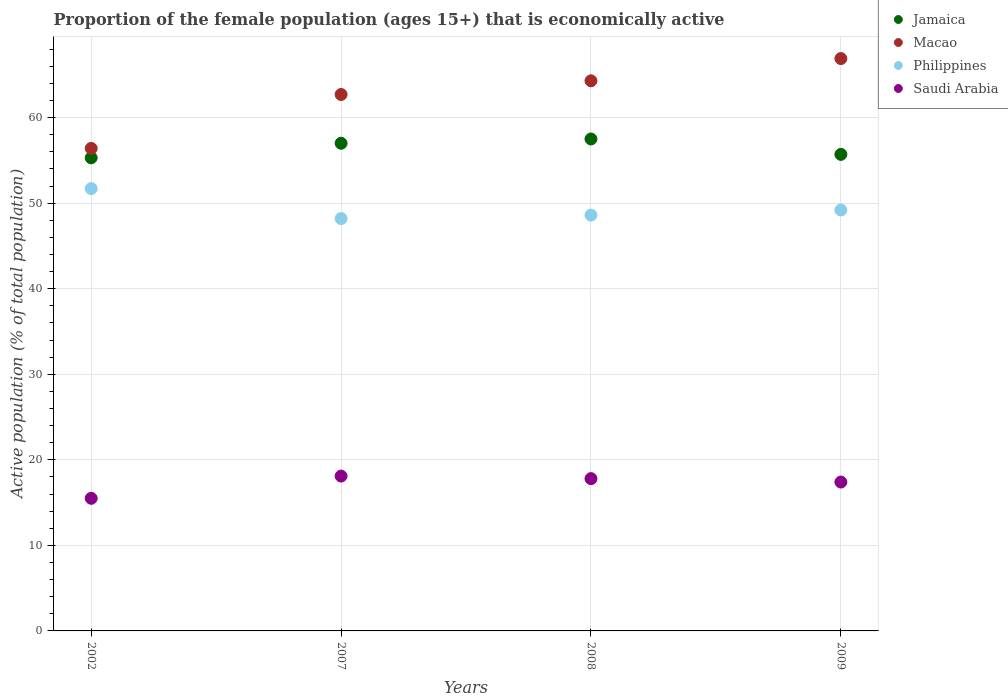Is the number of dotlines equal to the number of legend labels?
Your response must be concise. Yes. What is the proportion of the female population that is economically active in Saudi Arabia in 2008?
Keep it short and to the point. 17.8. Across all years, what is the maximum proportion of the female population that is economically active in Saudi Arabia?
Your response must be concise. 18.1. Across all years, what is the minimum proportion of the female population that is economically active in Saudi Arabia?
Offer a very short reply. 15.5. In which year was the proportion of the female population that is economically active in Philippines maximum?
Provide a short and direct response. 2002. What is the total proportion of the female population that is economically active in Philippines in the graph?
Provide a short and direct response. 197.7. What is the difference between the proportion of the female population that is economically active in Jamaica in 2007 and that in 2009?
Keep it short and to the point. 1.3. What is the difference between the proportion of the female population that is economically active in Jamaica in 2008 and the proportion of the female population that is economically active in Saudi Arabia in 2007?
Your answer should be compact. 39.4. What is the average proportion of the female population that is economically active in Philippines per year?
Your answer should be very brief. 49.43. In the year 2002, what is the difference between the proportion of the female population that is economically active in Philippines and proportion of the female population that is economically active in Saudi Arabia?
Provide a succinct answer. 36.2. What is the ratio of the proportion of the female population that is economically active in Saudi Arabia in 2007 to that in 2009?
Your response must be concise. 1.04. Is the difference between the proportion of the female population that is economically active in Philippines in 2002 and 2007 greater than the difference between the proportion of the female population that is economically active in Saudi Arabia in 2002 and 2007?
Your answer should be compact. Yes. What is the difference between the highest and the lowest proportion of the female population that is economically active in Macao?
Give a very brief answer. 10.5. Is the sum of the proportion of the female population that is economically active in Macao in 2002 and 2009 greater than the maximum proportion of the female population that is economically active in Saudi Arabia across all years?
Offer a terse response. Yes. Is it the case that in every year, the sum of the proportion of the female population that is economically active in Saudi Arabia and proportion of the female population that is economically active in Philippines  is greater than the sum of proportion of the female population that is economically active in Jamaica and proportion of the female population that is economically active in Macao?
Make the answer very short. Yes. Is it the case that in every year, the sum of the proportion of the female population that is economically active in Philippines and proportion of the female population that is economically active in Macao  is greater than the proportion of the female population that is economically active in Jamaica?
Ensure brevity in your answer.  Yes. Is the proportion of the female population that is economically active in Philippines strictly greater than the proportion of the female population that is economically active in Jamaica over the years?
Your answer should be very brief. No. Is the proportion of the female population that is economically active in Jamaica strictly less than the proportion of the female population that is economically active in Saudi Arabia over the years?
Provide a short and direct response. No. How many dotlines are there?
Your answer should be compact. 4. What is the difference between two consecutive major ticks on the Y-axis?
Your response must be concise. 10. Are the values on the major ticks of Y-axis written in scientific E-notation?
Your answer should be very brief. No. Does the graph contain any zero values?
Give a very brief answer. No. Where does the legend appear in the graph?
Provide a short and direct response. Top right. How many legend labels are there?
Ensure brevity in your answer.  4. What is the title of the graph?
Provide a short and direct response. Proportion of the female population (ages 15+) that is economically active. Does "Upper middle income" appear as one of the legend labels in the graph?
Your answer should be very brief. No. What is the label or title of the X-axis?
Make the answer very short. Years. What is the label or title of the Y-axis?
Offer a very short reply. Active population (% of total population). What is the Active population (% of total population) in Jamaica in 2002?
Give a very brief answer. 55.3. What is the Active population (% of total population) in Macao in 2002?
Provide a succinct answer. 56.4. What is the Active population (% of total population) of Philippines in 2002?
Offer a very short reply. 51.7. What is the Active population (% of total population) of Macao in 2007?
Your answer should be compact. 62.7. What is the Active population (% of total population) in Philippines in 2007?
Give a very brief answer. 48.2. What is the Active population (% of total population) of Saudi Arabia in 2007?
Offer a very short reply. 18.1. What is the Active population (% of total population) of Jamaica in 2008?
Provide a succinct answer. 57.5. What is the Active population (% of total population) in Macao in 2008?
Ensure brevity in your answer.  64.3. What is the Active population (% of total population) in Philippines in 2008?
Offer a terse response. 48.6. What is the Active population (% of total population) in Saudi Arabia in 2008?
Make the answer very short. 17.8. What is the Active population (% of total population) in Jamaica in 2009?
Give a very brief answer. 55.7. What is the Active population (% of total population) in Macao in 2009?
Your response must be concise. 66.9. What is the Active population (% of total population) in Philippines in 2009?
Provide a succinct answer. 49.2. What is the Active population (% of total population) of Saudi Arabia in 2009?
Offer a very short reply. 17.4. Across all years, what is the maximum Active population (% of total population) in Jamaica?
Your answer should be very brief. 57.5. Across all years, what is the maximum Active population (% of total population) of Macao?
Ensure brevity in your answer.  66.9. Across all years, what is the maximum Active population (% of total population) of Philippines?
Your answer should be compact. 51.7. Across all years, what is the maximum Active population (% of total population) of Saudi Arabia?
Your response must be concise. 18.1. Across all years, what is the minimum Active population (% of total population) in Jamaica?
Give a very brief answer. 55.3. Across all years, what is the minimum Active population (% of total population) of Macao?
Make the answer very short. 56.4. Across all years, what is the minimum Active population (% of total population) of Philippines?
Your answer should be compact. 48.2. What is the total Active population (% of total population) in Jamaica in the graph?
Offer a terse response. 225.5. What is the total Active population (% of total population) in Macao in the graph?
Offer a very short reply. 250.3. What is the total Active population (% of total population) in Philippines in the graph?
Your answer should be very brief. 197.7. What is the total Active population (% of total population) in Saudi Arabia in the graph?
Provide a succinct answer. 68.8. What is the difference between the Active population (% of total population) of Jamaica in 2002 and that in 2007?
Give a very brief answer. -1.7. What is the difference between the Active population (% of total population) in Macao in 2002 and that in 2007?
Provide a short and direct response. -6.3. What is the difference between the Active population (% of total population) of Macao in 2002 and that in 2008?
Provide a short and direct response. -7.9. What is the difference between the Active population (% of total population) in Philippines in 2002 and that in 2008?
Your answer should be compact. 3.1. What is the difference between the Active population (% of total population) of Saudi Arabia in 2002 and that in 2008?
Provide a short and direct response. -2.3. What is the difference between the Active population (% of total population) of Macao in 2002 and that in 2009?
Provide a short and direct response. -10.5. What is the difference between the Active population (% of total population) in Saudi Arabia in 2002 and that in 2009?
Your answer should be compact. -1.9. What is the difference between the Active population (% of total population) of Macao in 2007 and that in 2008?
Your answer should be compact. -1.6. What is the difference between the Active population (% of total population) in Jamaica in 2007 and that in 2009?
Your answer should be very brief. 1.3. What is the difference between the Active population (% of total population) of Jamaica in 2008 and that in 2009?
Ensure brevity in your answer.  1.8. What is the difference between the Active population (% of total population) of Macao in 2008 and that in 2009?
Your response must be concise. -2.6. What is the difference between the Active population (% of total population) of Jamaica in 2002 and the Active population (% of total population) of Macao in 2007?
Provide a short and direct response. -7.4. What is the difference between the Active population (% of total population) of Jamaica in 2002 and the Active population (% of total population) of Saudi Arabia in 2007?
Provide a succinct answer. 37.2. What is the difference between the Active population (% of total population) in Macao in 2002 and the Active population (% of total population) in Philippines in 2007?
Provide a short and direct response. 8.2. What is the difference between the Active population (% of total population) in Macao in 2002 and the Active population (% of total population) in Saudi Arabia in 2007?
Provide a succinct answer. 38.3. What is the difference between the Active population (% of total population) in Philippines in 2002 and the Active population (% of total population) in Saudi Arabia in 2007?
Offer a very short reply. 33.6. What is the difference between the Active population (% of total population) of Jamaica in 2002 and the Active population (% of total population) of Saudi Arabia in 2008?
Provide a succinct answer. 37.5. What is the difference between the Active population (% of total population) in Macao in 2002 and the Active population (% of total population) in Saudi Arabia in 2008?
Offer a terse response. 38.6. What is the difference between the Active population (% of total population) of Philippines in 2002 and the Active population (% of total population) of Saudi Arabia in 2008?
Provide a succinct answer. 33.9. What is the difference between the Active population (% of total population) of Jamaica in 2002 and the Active population (% of total population) of Macao in 2009?
Provide a short and direct response. -11.6. What is the difference between the Active population (% of total population) of Jamaica in 2002 and the Active population (% of total population) of Philippines in 2009?
Keep it short and to the point. 6.1. What is the difference between the Active population (% of total population) of Jamaica in 2002 and the Active population (% of total population) of Saudi Arabia in 2009?
Give a very brief answer. 37.9. What is the difference between the Active population (% of total population) of Macao in 2002 and the Active population (% of total population) of Saudi Arabia in 2009?
Offer a very short reply. 39. What is the difference between the Active population (% of total population) of Philippines in 2002 and the Active population (% of total population) of Saudi Arabia in 2009?
Make the answer very short. 34.3. What is the difference between the Active population (% of total population) of Jamaica in 2007 and the Active population (% of total population) of Macao in 2008?
Your answer should be very brief. -7.3. What is the difference between the Active population (% of total population) in Jamaica in 2007 and the Active population (% of total population) in Philippines in 2008?
Provide a succinct answer. 8.4. What is the difference between the Active population (% of total population) in Jamaica in 2007 and the Active population (% of total population) in Saudi Arabia in 2008?
Keep it short and to the point. 39.2. What is the difference between the Active population (% of total population) in Macao in 2007 and the Active population (% of total population) in Philippines in 2008?
Your response must be concise. 14.1. What is the difference between the Active population (% of total population) in Macao in 2007 and the Active population (% of total population) in Saudi Arabia in 2008?
Keep it short and to the point. 44.9. What is the difference between the Active population (% of total population) of Philippines in 2007 and the Active population (% of total population) of Saudi Arabia in 2008?
Keep it short and to the point. 30.4. What is the difference between the Active population (% of total population) in Jamaica in 2007 and the Active population (% of total population) in Macao in 2009?
Your answer should be very brief. -9.9. What is the difference between the Active population (% of total population) of Jamaica in 2007 and the Active population (% of total population) of Saudi Arabia in 2009?
Make the answer very short. 39.6. What is the difference between the Active population (% of total population) in Macao in 2007 and the Active population (% of total population) in Philippines in 2009?
Offer a very short reply. 13.5. What is the difference between the Active population (% of total population) in Macao in 2007 and the Active population (% of total population) in Saudi Arabia in 2009?
Your answer should be very brief. 45.3. What is the difference between the Active population (% of total population) in Philippines in 2007 and the Active population (% of total population) in Saudi Arabia in 2009?
Give a very brief answer. 30.8. What is the difference between the Active population (% of total population) in Jamaica in 2008 and the Active population (% of total population) in Saudi Arabia in 2009?
Offer a terse response. 40.1. What is the difference between the Active population (% of total population) of Macao in 2008 and the Active population (% of total population) of Saudi Arabia in 2009?
Offer a very short reply. 46.9. What is the difference between the Active population (% of total population) of Philippines in 2008 and the Active population (% of total population) of Saudi Arabia in 2009?
Keep it short and to the point. 31.2. What is the average Active population (% of total population) in Jamaica per year?
Offer a very short reply. 56.38. What is the average Active population (% of total population) in Macao per year?
Give a very brief answer. 62.58. What is the average Active population (% of total population) in Philippines per year?
Keep it short and to the point. 49.42. What is the average Active population (% of total population) in Saudi Arabia per year?
Your response must be concise. 17.2. In the year 2002, what is the difference between the Active population (% of total population) of Jamaica and Active population (% of total population) of Macao?
Your answer should be very brief. -1.1. In the year 2002, what is the difference between the Active population (% of total population) of Jamaica and Active population (% of total population) of Philippines?
Provide a succinct answer. 3.6. In the year 2002, what is the difference between the Active population (% of total population) in Jamaica and Active population (% of total population) in Saudi Arabia?
Offer a terse response. 39.8. In the year 2002, what is the difference between the Active population (% of total population) of Macao and Active population (% of total population) of Philippines?
Your response must be concise. 4.7. In the year 2002, what is the difference between the Active population (% of total population) in Macao and Active population (% of total population) in Saudi Arabia?
Your answer should be very brief. 40.9. In the year 2002, what is the difference between the Active population (% of total population) in Philippines and Active population (% of total population) in Saudi Arabia?
Your response must be concise. 36.2. In the year 2007, what is the difference between the Active population (% of total population) in Jamaica and Active population (% of total population) in Saudi Arabia?
Your answer should be very brief. 38.9. In the year 2007, what is the difference between the Active population (% of total population) of Macao and Active population (% of total population) of Philippines?
Your answer should be very brief. 14.5. In the year 2007, what is the difference between the Active population (% of total population) of Macao and Active population (% of total population) of Saudi Arabia?
Your response must be concise. 44.6. In the year 2007, what is the difference between the Active population (% of total population) in Philippines and Active population (% of total population) in Saudi Arabia?
Offer a terse response. 30.1. In the year 2008, what is the difference between the Active population (% of total population) in Jamaica and Active population (% of total population) in Macao?
Your answer should be compact. -6.8. In the year 2008, what is the difference between the Active population (% of total population) in Jamaica and Active population (% of total population) in Saudi Arabia?
Ensure brevity in your answer.  39.7. In the year 2008, what is the difference between the Active population (% of total population) in Macao and Active population (% of total population) in Philippines?
Provide a short and direct response. 15.7. In the year 2008, what is the difference between the Active population (% of total population) in Macao and Active population (% of total population) in Saudi Arabia?
Your answer should be very brief. 46.5. In the year 2008, what is the difference between the Active population (% of total population) of Philippines and Active population (% of total population) of Saudi Arabia?
Provide a short and direct response. 30.8. In the year 2009, what is the difference between the Active population (% of total population) of Jamaica and Active population (% of total population) of Saudi Arabia?
Offer a terse response. 38.3. In the year 2009, what is the difference between the Active population (% of total population) in Macao and Active population (% of total population) in Saudi Arabia?
Your answer should be very brief. 49.5. In the year 2009, what is the difference between the Active population (% of total population) of Philippines and Active population (% of total population) of Saudi Arabia?
Your answer should be very brief. 31.8. What is the ratio of the Active population (% of total population) of Jamaica in 2002 to that in 2007?
Make the answer very short. 0.97. What is the ratio of the Active population (% of total population) of Macao in 2002 to that in 2007?
Make the answer very short. 0.9. What is the ratio of the Active population (% of total population) of Philippines in 2002 to that in 2007?
Your answer should be compact. 1.07. What is the ratio of the Active population (% of total population) in Saudi Arabia in 2002 to that in 2007?
Your response must be concise. 0.86. What is the ratio of the Active population (% of total population) of Jamaica in 2002 to that in 2008?
Your response must be concise. 0.96. What is the ratio of the Active population (% of total population) of Macao in 2002 to that in 2008?
Provide a short and direct response. 0.88. What is the ratio of the Active population (% of total population) of Philippines in 2002 to that in 2008?
Keep it short and to the point. 1.06. What is the ratio of the Active population (% of total population) of Saudi Arabia in 2002 to that in 2008?
Give a very brief answer. 0.87. What is the ratio of the Active population (% of total population) in Jamaica in 2002 to that in 2009?
Your response must be concise. 0.99. What is the ratio of the Active population (% of total population) of Macao in 2002 to that in 2009?
Keep it short and to the point. 0.84. What is the ratio of the Active population (% of total population) of Philippines in 2002 to that in 2009?
Provide a succinct answer. 1.05. What is the ratio of the Active population (% of total population) in Saudi Arabia in 2002 to that in 2009?
Offer a terse response. 0.89. What is the ratio of the Active population (% of total population) of Macao in 2007 to that in 2008?
Provide a succinct answer. 0.98. What is the ratio of the Active population (% of total population) of Saudi Arabia in 2007 to that in 2008?
Offer a very short reply. 1.02. What is the ratio of the Active population (% of total population) in Jamaica in 2007 to that in 2009?
Offer a terse response. 1.02. What is the ratio of the Active population (% of total population) of Macao in 2007 to that in 2009?
Make the answer very short. 0.94. What is the ratio of the Active population (% of total population) in Philippines in 2007 to that in 2009?
Keep it short and to the point. 0.98. What is the ratio of the Active population (% of total population) of Saudi Arabia in 2007 to that in 2009?
Offer a terse response. 1.04. What is the ratio of the Active population (% of total population) in Jamaica in 2008 to that in 2009?
Offer a terse response. 1.03. What is the ratio of the Active population (% of total population) in Macao in 2008 to that in 2009?
Offer a very short reply. 0.96. What is the difference between the highest and the second highest Active population (% of total population) of Jamaica?
Your answer should be very brief. 0.5. What is the difference between the highest and the second highest Active population (% of total population) in Saudi Arabia?
Offer a terse response. 0.3. 